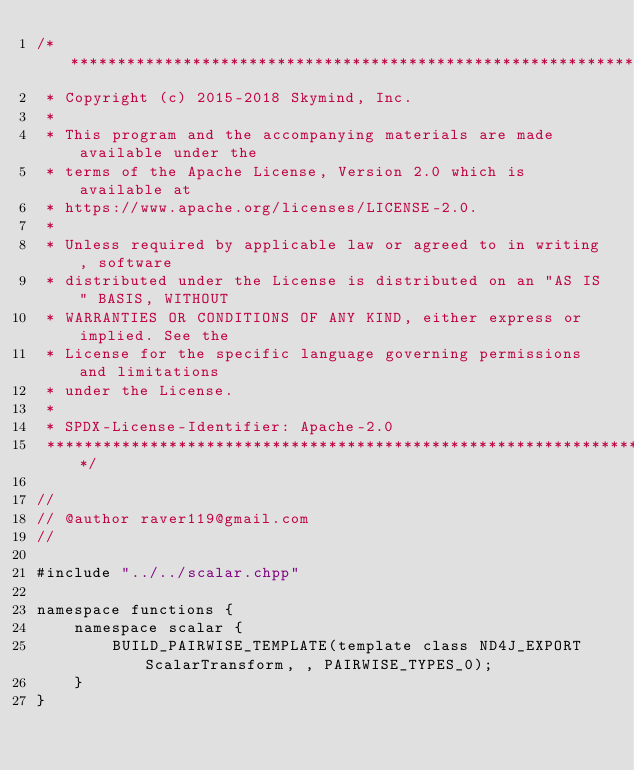Convert code to text. <code><loc_0><loc_0><loc_500><loc_500><_Cuda_>/*******************************************************************************
 * Copyright (c) 2015-2018 Skymind, Inc.
 *
 * This program and the accompanying materials are made available under the
 * terms of the Apache License, Version 2.0 which is available at
 * https://www.apache.org/licenses/LICENSE-2.0.
 *
 * Unless required by applicable law or agreed to in writing, software
 * distributed under the License is distributed on an "AS IS" BASIS, WITHOUT
 * WARRANTIES OR CONDITIONS OF ANY KIND, either express or implied. See the
 * License for the specific language governing permissions and limitations
 * under the License.
 *
 * SPDX-License-Identifier: Apache-2.0
 ******************************************************************************/

//
// @author raver119@gmail.com
//

#include "../../scalar.chpp"

namespace functions {
    namespace scalar {
        BUILD_PAIRWISE_TEMPLATE(template class ND4J_EXPORT ScalarTransform, , PAIRWISE_TYPES_0);
    }
}</code> 